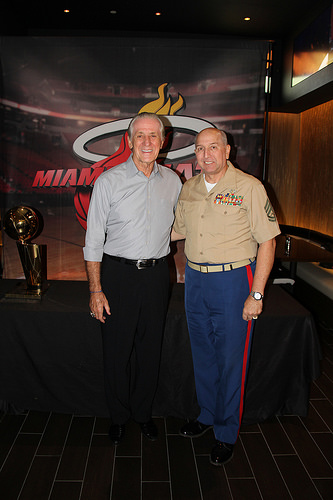<image>
Is there a trophy behind the man? Yes. From this viewpoint, the trophy is positioned behind the man, with the man partially or fully occluding the trophy. 